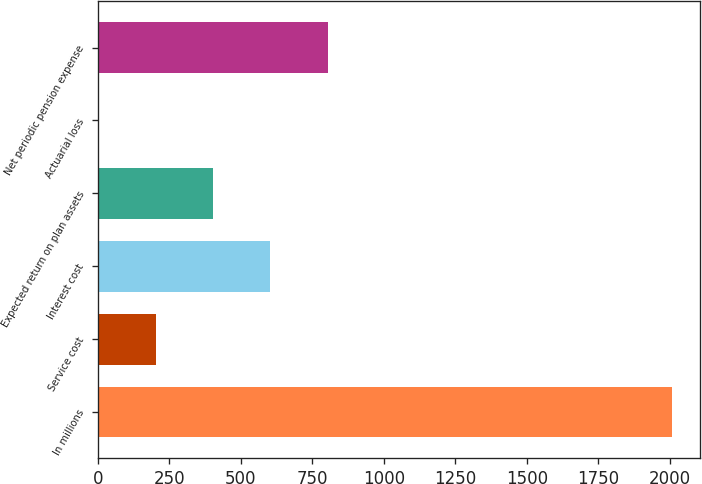Convert chart to OTSL. <chart><loc_0><loc_0><loc_500><loc_500><bar_chart><fcel>In millions<fcel>Service cost<fcel>Interest cost<fcel>Expected return on plan assets<fcel>Actuarial loss<fcel>Net periodic pension expense<nl><fcel>2006<fcel>202.4<fcel>603.2<fcel>402.8<fcel>2<fcel>803.6<nl></chart> 